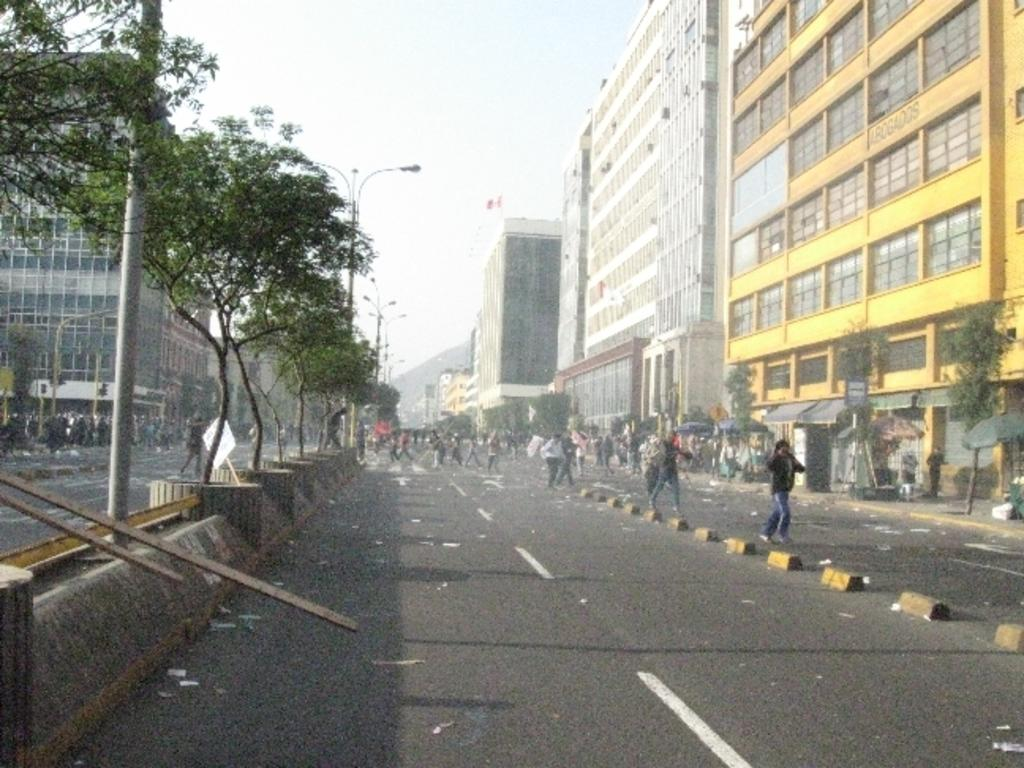What is the main subject of the image? The main subject of the image is a group of people. What can be seen in the background of the image? In the background of the image, there are poles, lights, buildings, and trees. Can you describe the setting of the image? The image appears to be set in an urban environment with buildings and trees in the background. What type of horse can be seen in the image? There is no horse present in the image; it features a group of people and various background elements. What is the reason for the people gathering in the image? The image does not provide any information about the reason for the people gathering; we can only observe that they are present in the image. 